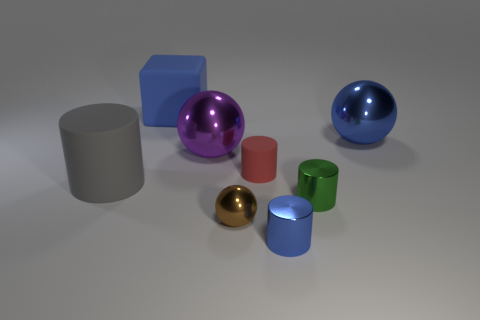What number of other things are the same color as the big rubber block?
Ensure brevity in your answer.  2. Are there fewer big blue things in front of the blue cube than tiny red shiny spheres?
Give a very brief answer. No. Are there any blue things of the same size as the red rubber cylinder?
Provide a succinct answer. Yes. There is a large rubber cube; does it have the same color as the metallic cylinder in front of the green shiny thing?
Your answer should be very brief. Yes. What number of cubes are in front of the matte cylinder that is on the left side of the brown sphere?
Keep it short and to the point. 0. There is a small metal object that is to the left of the blue metallic object to the left of the big blue shiny ball; what is its color?
Provide a succinct answer. Brown. What is the object that is both on the left side of the small red thing and in front of the gray rubber thing made of?
Make the answer very short. Metal. Is there a large blue shiny object that has the same shape as the red rubber thing?
Provide a succinct answer. No. Is the shape of the metallic thing that is left of the brown object the same as  the brown metal thing?
Offer a very short reply. Yes. How many big objects are both on the left side of the big purple metal object and behind the gray cylinder?
Provide a short and direct response. 1. 